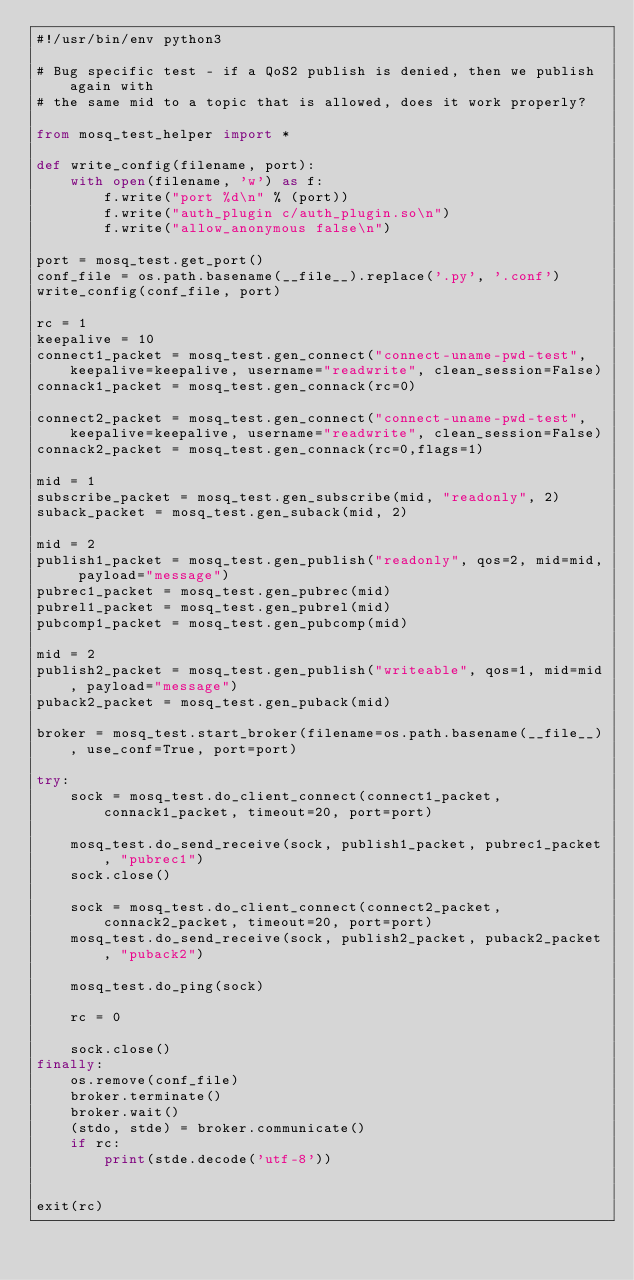<code> <loc_0><loc_0><loc_500><loc_500><_Python_>#!/usr/bin/env python3

# Bug specific test - if a QoS2 publish is denied, then we publish again with
# the same mid to a topic that is allowed, does it work properly?

from mosq_test_helper import *

def write_config(filename, port):
    with open(filename, 'w') as f:
        f.write("port %d\n" % (port))
        f.write("auth_plugin c/auth_plugin.so\n")
        f.write("allow_anonymous false\n")

port = mosq_test.get_port()
conf_file = os.path.basename(__file__).replace('.py', '.conf')
write_config(conf_file, port)

rc = 1
keepalive = 10
connect1_packet = mosq_test.gen_connect("connect-uname-pwd-test", keepalive=keepalive, username="readwrite", clean_session=False)
connack1_packet = mosq_test.gen_connack(rc=0)

connect2_packet = mosq_test.gen_connect("connect-uname-pwd-test", keepalive=keepalive, username="readwrite", clean_session=False)
connack2_packet = mosq_test.gen_connack(rc=0,flags=1)

mid = 1
subscribe_packet = mosq_test.gen_subscribe(mid, "readonly", 2)
suback_packet = mosq_test.gen_suback(mid, 2)

mid = 2
publish1_packet = mosq_test.gen_publish("readonly", qos=2, mid=mid, payload="message")
pubrec1_packet = mosq_test.gen_pubrec(mid)
pubrel1_packet = mosq_test.gen_pubrel(mid)
pubcomp1_packet = mosq_test.gen_pubcomp(mid)

mid = 2
publish2_packet = mosq_test.gen_publish("writeable", qos=1, mid=mid, payload="message")
puback2_packet = mosq_test.gen_puback(mid)

broker = mosq_test.start_broker(filename=os.path.basename(__file__), use_conf=True, port=port)

try:
    sock = mosq_test.do_client_connect(connect1_packet, connack1_packet, timeout=20, port=port)

    mosq_test.do_send_receive(sock, publish1_packet, pubrec1_packet, "pubrec1")
    sock.close()

    sock = mosq_test.do_client_connect(connect2_packet, connack2_packet, timeout=20, port=port)
    mosq_test.do_send_receive(sock, publish2_packet, puback2_packet, "puback2")

    mosq_test.do_ping(sock)

    rc = 0

    sock.close()
finally:
    os.remove(conf_file)
    broker.terminate()
    broker.wait()
    (stdo, stde) = broker.communicate()
    if rc:
        print(stde.decode('utf-8'))


exit(rc)
</code> 